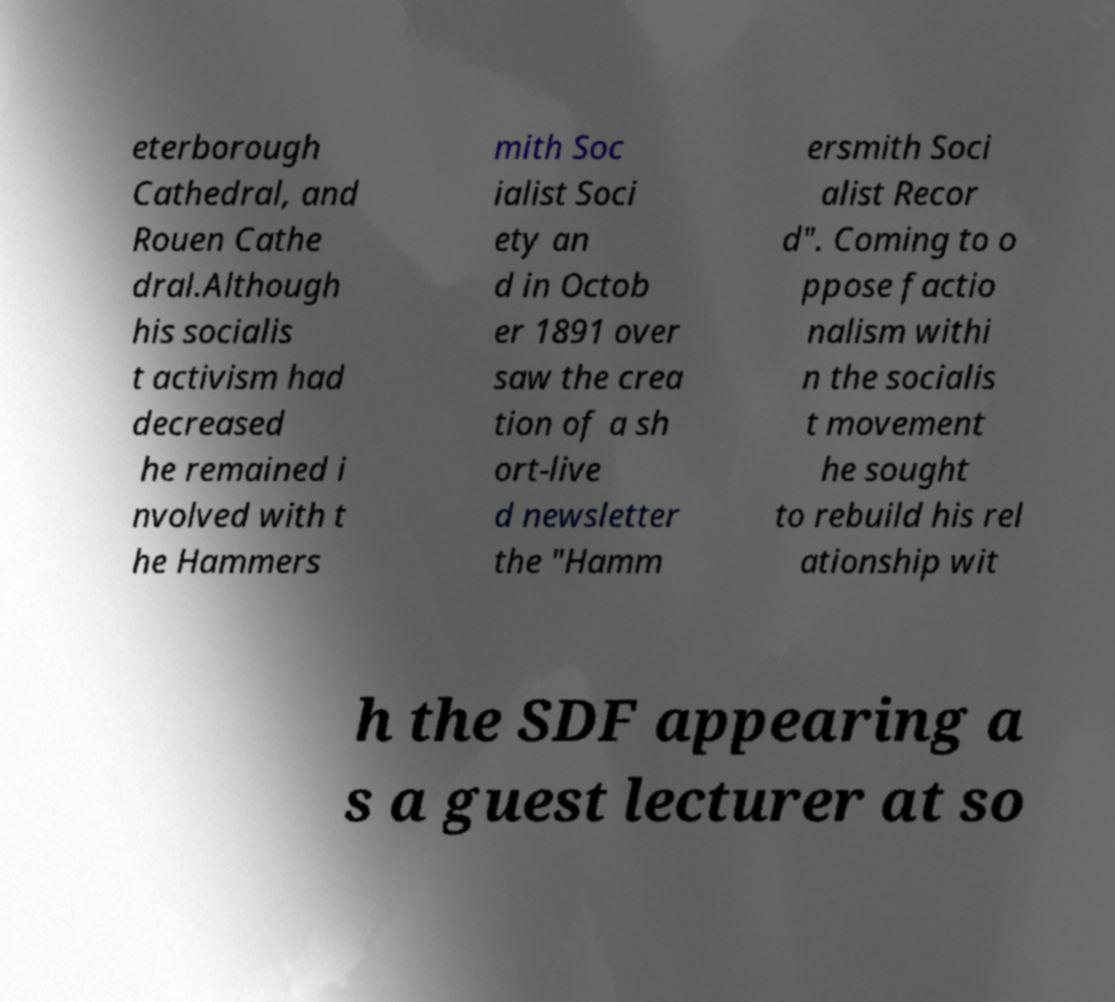Could you extract and type out the text from this image? eterborough Cathedral, and Rouen Cathe dral.Although his socialis t activism had decreased he remained i nvolved with t he Hammers mith Soc ialist Soci ety an d in Octob er 1891 over saw the crea tion of a sh ort-live d newsletter the "Hamm ersmith Soci alist Recor d". Coming to o ppose factio nalism withi n the socialis t movement he sought to rebuild his rel ationship wit h the SDF appearing a s a guest lecturer at so 